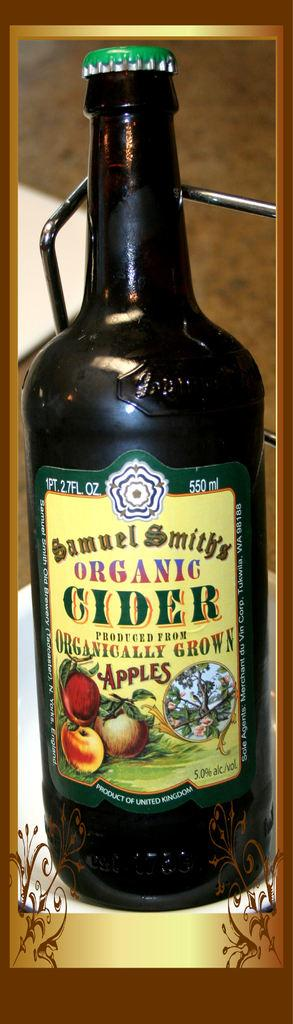<image>
Give a short and clear explanation of the subsequent image. a green bottle of Samuel Smith's Organic Cider 550 ml 